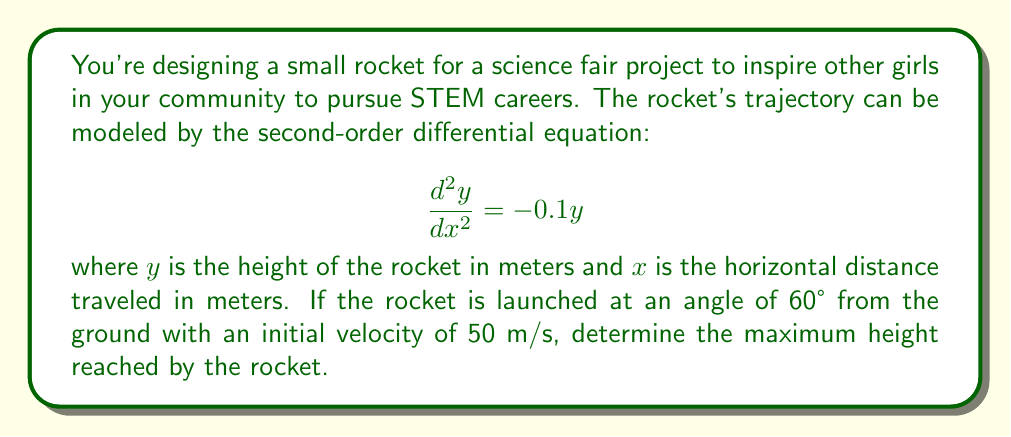Could you help me with this problem? Let's approach this step-by-step:

1) The general solution to the given differential equation is:
   $$y = A \cos(kx) + B \sin(kx)$$
   where $k^2 = 0.1$, so $k = \sqrt{0.1} \approx 0.3162$

2) We need to find $A$ and $B$ using the initial conditions. Let's set up a coordinate system where the rocket is launched from the origin (0,0).

3) Initial velocity components:
   - Vertical: $v_y = 50 \sin(60°) = 43.3$ m/s
   - Horizontal: $v_x = 50 \cos(60°) = 25$ m/s

4) Initial conditions:
   At $x = 0$: $y = 0$ and $\frac{dy}{dx} = \frac{v_y}{v_x} = \frac{43.3}{25} = 1.732$

5) Applying the initial conditions:
   $y(0) = 0$: $0 = A \cos(0) + B \sin(0)$, so $A = 0$
   $\frac{dy}{dx}(0) = 1.732$: $1.732 = -0.3162A \sin(0) + 0.3162B \cos(0)$, so $B = 5.478$

6) The trajectory equation is therefore:
   $$y = 5.478 \sin(0.3162x)$$

7) To find the maximum height, we need to find where $\frac{dy}{dx} = 0$:
   $$\frac{dy}{dx} = 1.732 \cos(0.3162x)$$
   This is zero when $\cos(0.3162x) = 0$, which occurs when $0.3162x = \frac{\pi}{2}$

8) Solving for $x$:
   $$x = \frac{\pi}{2 \cdot 0.3162} \approx 4.964$$

9) The maximum height is reached at this $x$-value:
   $$y_{max} = 5.478 \sin(0.3162 \cdot 4.964) = 5.478$$
Answer: The maximum height reached by the rocket is approximately 5.478 meters. 